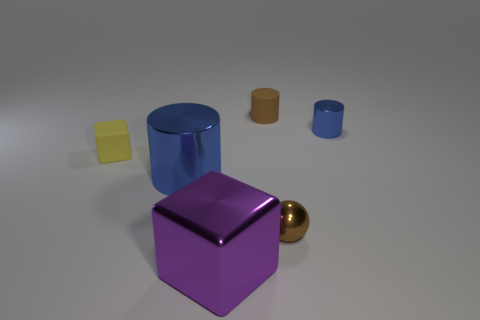What number of tiny things are the same color as the small ball?
Your answer should be compact. 1. There is a blue thing that is the same size as the yellow matte object; what is its shape?
Provide a short and direct response. Cylinder. How many small objects are green balls or cubes?
Keep it short and to the point. 1. The other large object that is made of the same material as the large blue object is what color?
Offer a terse response. Purple. There is a rubber thing that is left of the small brown rubber cylinder; is its shape the same as the big object in front of the brown metallic ball?
Keep it short and to the point. Yes. What number of metallic objects are tiny brown objects or cubes?
Your response must be concise. 2. There is a small sphere that is the same color as the tiny matte cylinder; what is it made of?
Your answer should be very brief. Metal. Are there any other things that have the same shape as the yellow matte thing?
Offer a terse response. Yes. What is the material of the tiny cylinder that is behind the tiny blue metal thing?
Your response must be concise. Rubber. Is the material of the tiny brown object behind the small blue cylinder the same as the large block?
Give a very brief answer. No. 